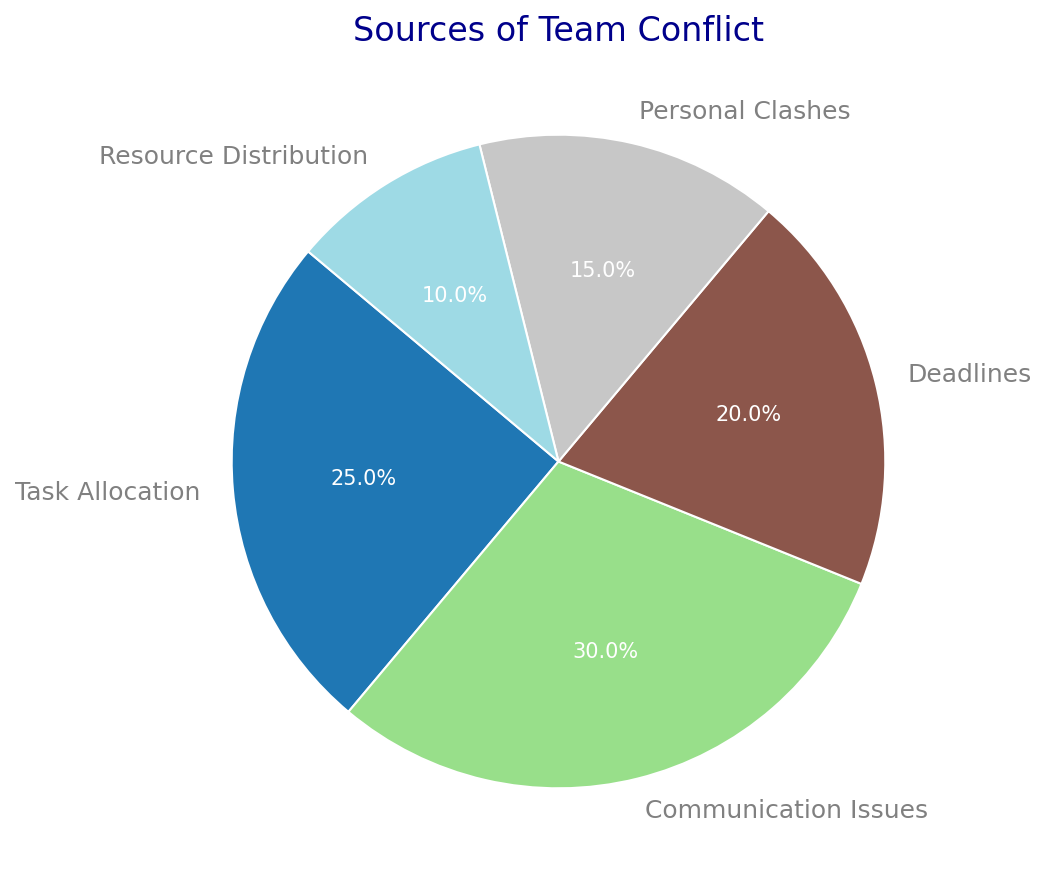What's the largest source of team conflict? The pie chart shows the percentage for each conflict source. The largest segment is for Communication Issues, which is 30%.
Answer: Communication Issues Which conflict source has a lower percentage than Deadlines but higher than Resource Distribution? Both Deadlines (20%) and Resource Distribution (10%) are shown in the pie chart. The conflict source between these values is Personal Clashes, which is 15%.
Answer: Personal Clashes What is the combined percentage of Task Allocation and Personal Clashes? Task Allocation is 25% and Personal Clashes is 15%. Adding these together: 25% + 15% = 40%.
Answer: 40% Are Task Allocation and Deadlines collectively accounting for more than half of the team conflicts? Task Allocation is 25% and Deadlines is 20%. Summing these: 25% + 20% = 45%, which is less than 50%.
Answer: No Which conflict source is least significant according to the pie chart? By looking at the percentages, Resource Distribution has the smallest portion at 10%.
Answer: Resource Distribution How much could be gained (in percentage points) by solving Communication Issues and personal clashes together? Communication Issues is 30% and Personal Clashes is 15%. The total is calculated: 30% + 15% = 45%.
Answer: 45% Which conflict source is depicted using the darkest shade in the pie chart? Visual inspection of the pie chart reveals that the darkest shade corresponds to Communication Issues.
Answer: Communication Issues What percentage of team conflicts are not related to Communication Issues? Communication Issues account for 30%. Subtracting from 100% gives: 100% - 30% = 70%.
Answer: 70% Compare the ratios between Task Allocation and Resource Distribution. Task Allocation is 25%, and Resource Distribution is 10%. The ratio is calculated as 25:10 or 2.5:1.
Answer: 2.5:1 Which two conflict sources together make up exactly half of the team conflict? Adding Communication Issues (30%) and Deadlines (20%) together equals 50%. No other pairs add up to 50%.
Answer: Communication Issues and Deadlines 